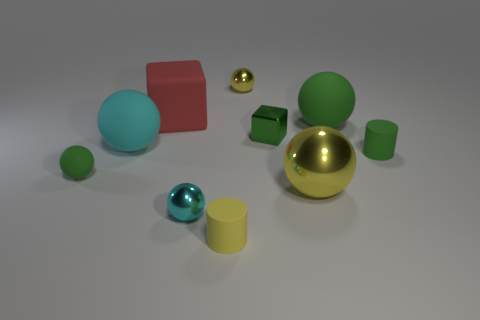Subtract all small green balls. How many balls are left? 5 Subtract all yellow cylinders. How many green spheres are left? 2 Subtract all green spheres. How many spheres are left? 4 Subtract 1 balls. How many balls are left? 5 Subtract all cubes. How many objects are left? 8 Subtract all cyan balls. Subtract all cyan cubes. How many balls are left? 4 Subtract all tiny blue rubber cubes. Subtract all small green cubes. How many objects are left? 9 Add 6 green cylinders. How many green cylinders are left? 7 Add 1 tiny green shiny things. How many tiny green shiny things exist? 2 Subtract 1 red cubes. How many objects are left? 9 